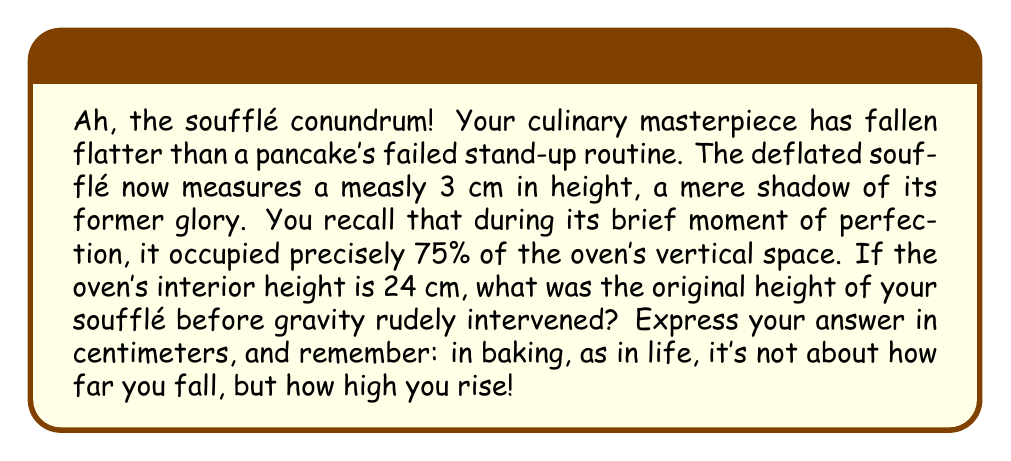Help me with this question. Let's rise to the occasion and solve this deflating problem step-by-step:

1) First, let's define our variables:
   $h$ = original height of the soufflé
   $H$ = height of the oven interior (given as 24 cm)

2) We're told that the soufflé, at its peak, occupied 75% of the oven's height. This can be expressed as:

   $$h = 0.75H$$

3) Now, let's substitute the known value of $H$:

   $$h = 0.75 \times 24 \text{ cm}$$

4) Time to whip up the final calculation:

   $$h = 18 \text{ cm}$$

5) As a sanity check, let's confirm that 18 cm is indeed 75% of 24 cm:

   $$\frac{18}{24} = 0.75 = 75\%$$

Thus, our calculation stands tall and proud, much like your soufflé once did.
Answer: 18 cm 